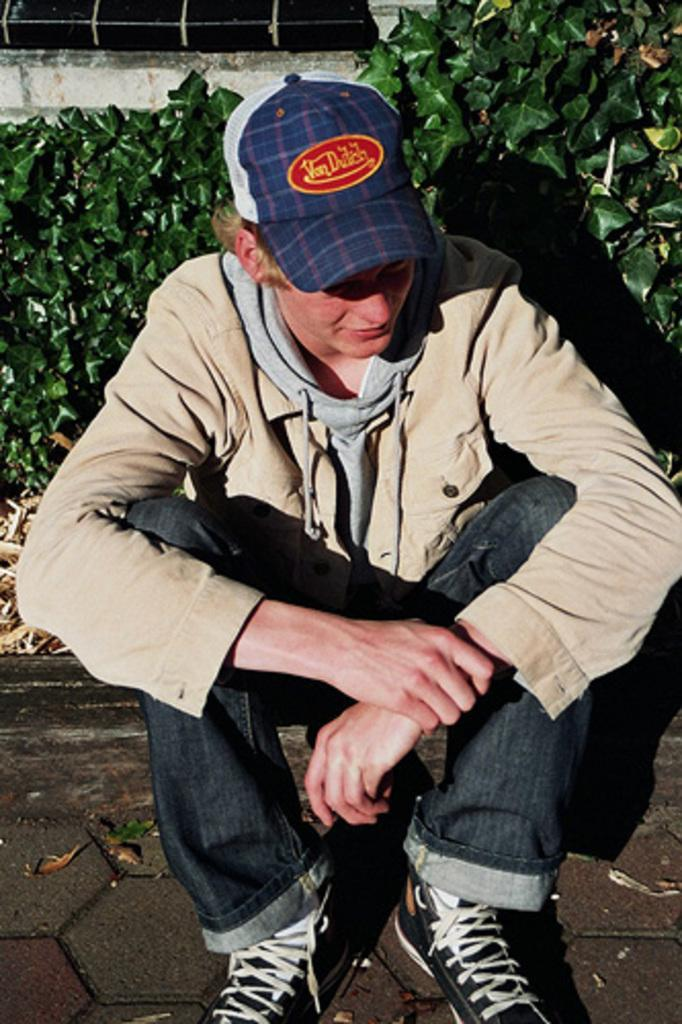What is the main subject of the image? There is a man sitting in the center of the image. What can be seen in the background of the image? There are plants and a window visible in the background of the image. What is at the bottom of the image? There is a road visible at the bottom of the image. How many pairs of shoes can be seen in the image? There are no shoes visible in the image. Are there any snakes present in the image? There are no snakes present in the image. 